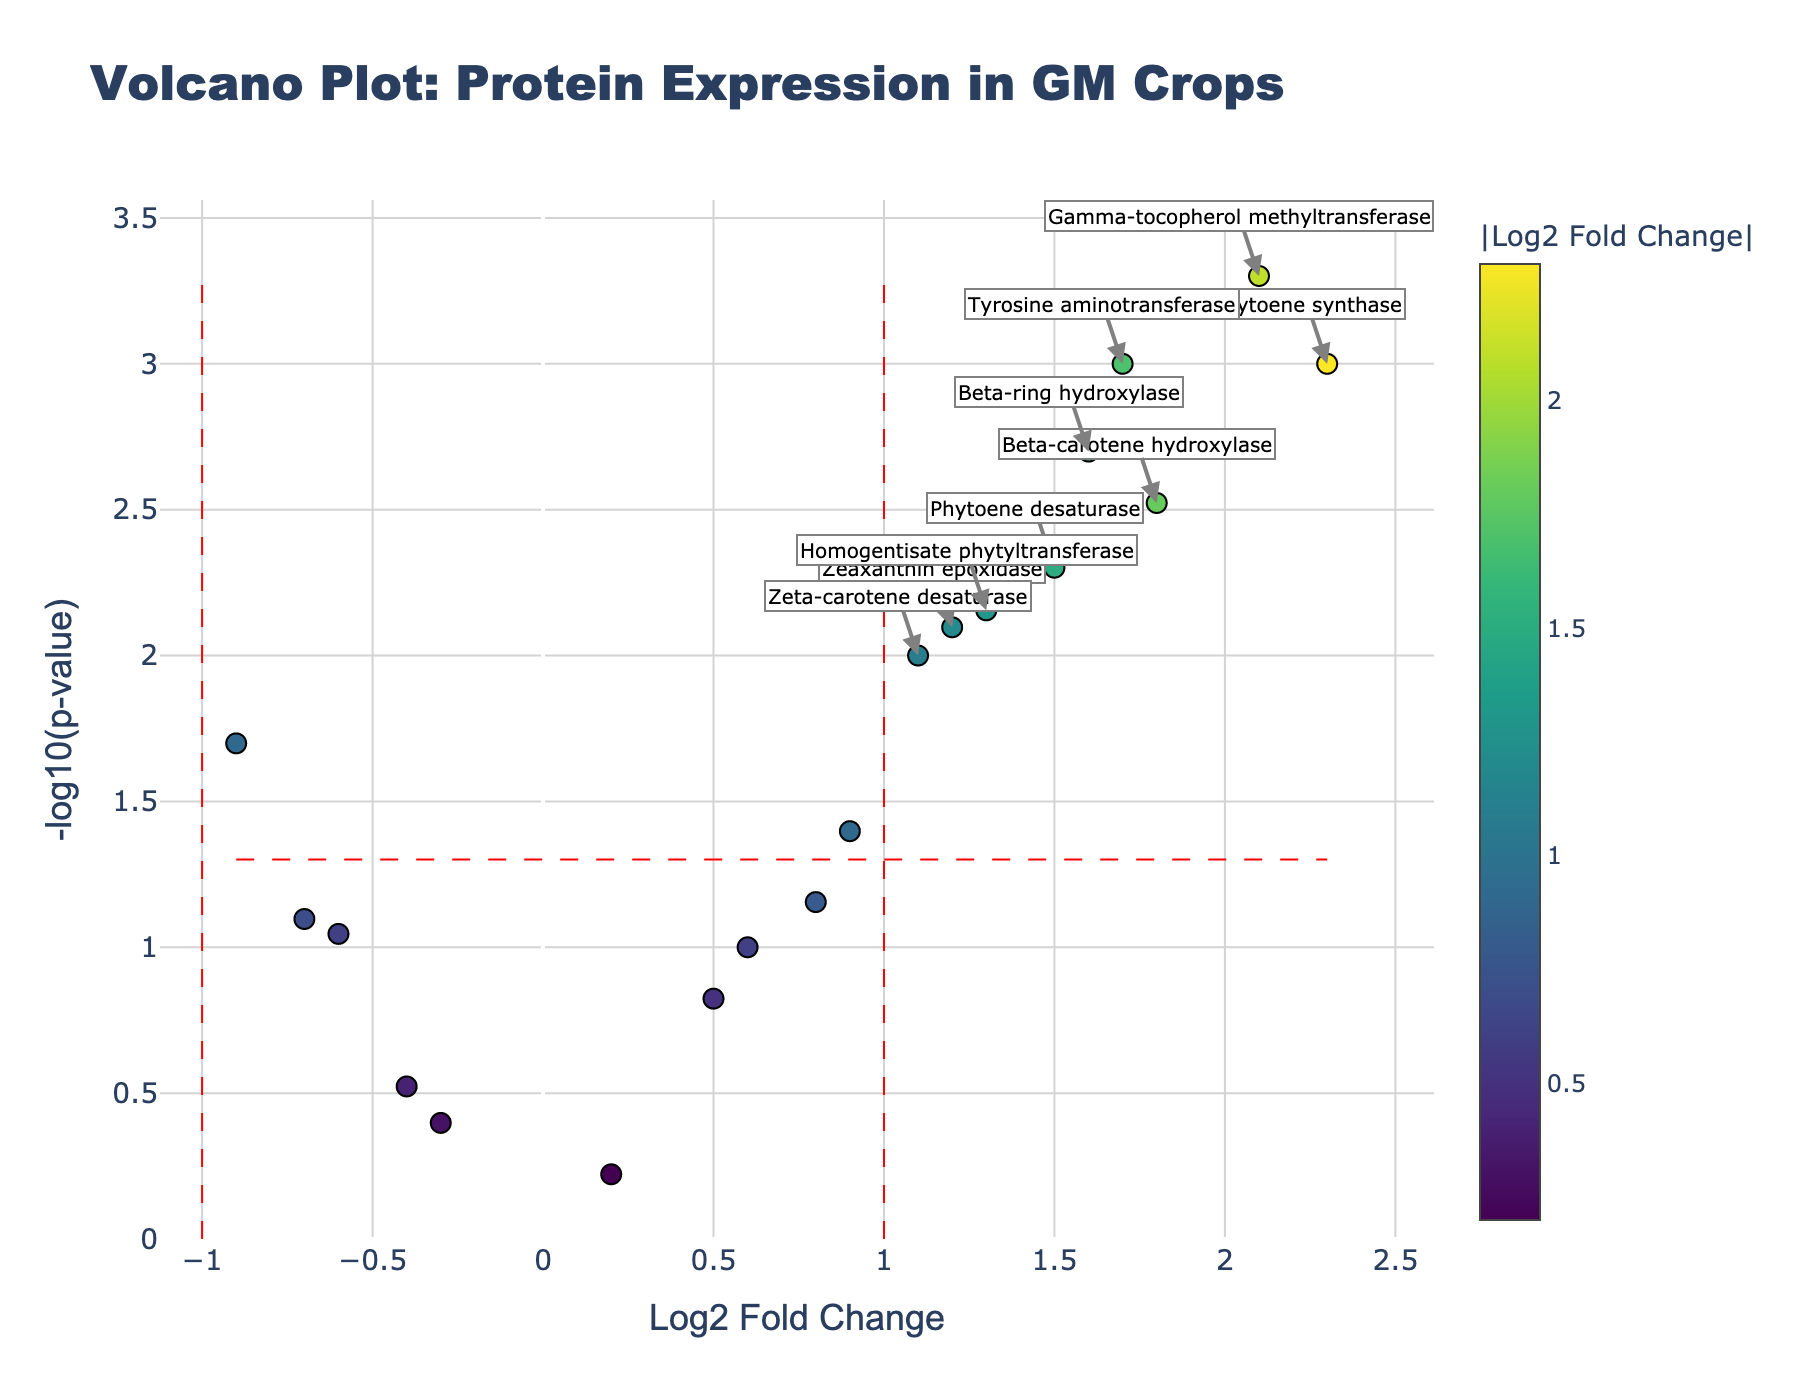What is the title of the plot? The title of the plot is given at the top of the figure.
Answer: Volcano Plot: Protein Expression in GM Crops What does the x-axis represent? The x-axis represents the log2 fold change, indicating how much the protein expression has changed.
Answer: Log2 Fold Change What does the y-axis represent? The y-axis represents the negative logarithm of the p-value, indicating the statistical significance of the change in protein expression.
Answer: -log10(p-value) How many proteins have a log2 fold change greater than 1? By counting the data points to the right of the vertical red line at x = 1, we determine the number of proteins with a log2 fold change greater than 1.
Answer: 7 Which proteins are considered significant based on fold change (>1 or <-1) and p-value (<0.05)? Proteins are considered significant if they fall outside the vertical lines at x = 1 or x = -1, and above the horizontal line at -log10(0.05). Look for annotated proteins.
Answer: Phytoene synthase, Beta-carotene hydroxylase, Phytoene desaturase, Zeta-carotene desaturase, Beta-ring hydroxylase, Gamma-tocopherol methyltransferase, Tyrosine aminotransferase, Homogentisate phytyltransferase, Zeaxanthin epoxidase Which proteins have the most significant p-values? The most significant p-values are at the highest y-axis positions.
Answer: Gamma-tocopherol methyltransferase, Tyrosine aminotransferase What is the log2 fold change for Gamma-tocopherol methyltransferase? Check the x-axis value for Gamma-tocopherol methyltransferase's position.
Answer: 2.1 Which protein exhibited the largest upregulation? Look for the data point furthest to the right (highest positive log2 fold change).
Answer: Gamma-tocopherol methyltransferase Is there any protein with a p-value higher than 0.1 and log2 fold change higher than 1? Check for data points where both conditions are met (y-axis lower because -log10(p-value) is lower, x-axis greater than 1).
Answer: No Which protein has the smallest negative log2 fold change? Find the data point furthest to the left (most negative log2 fold change).
Answer: Lycopene epsilon-cyclase 